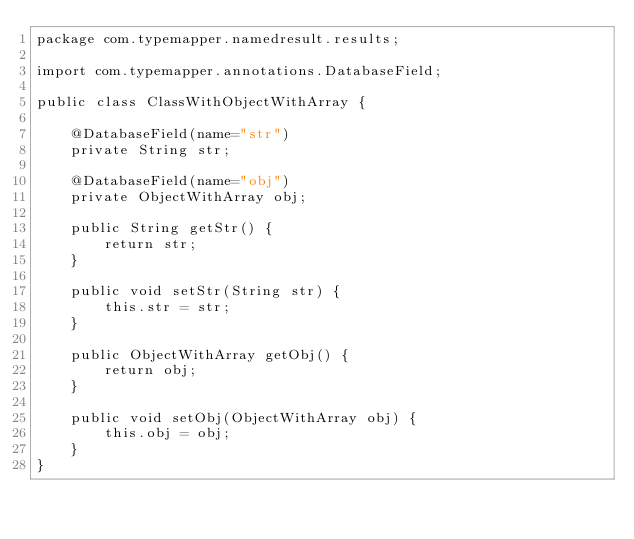Convert code to text. <code><loc_0><loc_0><loc_500><loc_500><_Java_>package com.typemapper.namedresult.results;

import com.typemapper.annotations.DatabaseField;

public class ClassWithObjectWithArray {
	
	@DatabaseField(name="str")
	private String str;
	
	@DatabaseField(name="obj")
	private ObjectWithArray obj;

	public String getStr() {
		return str;
	}

	public void setStr(String str) {
		this.str = str;
	}

	public ObjectWithArray getObj() {
		return obj;
	}

	public void setObj(ObjectWithArray obj) {
		this.obj = obj;
	}
}
</code> 